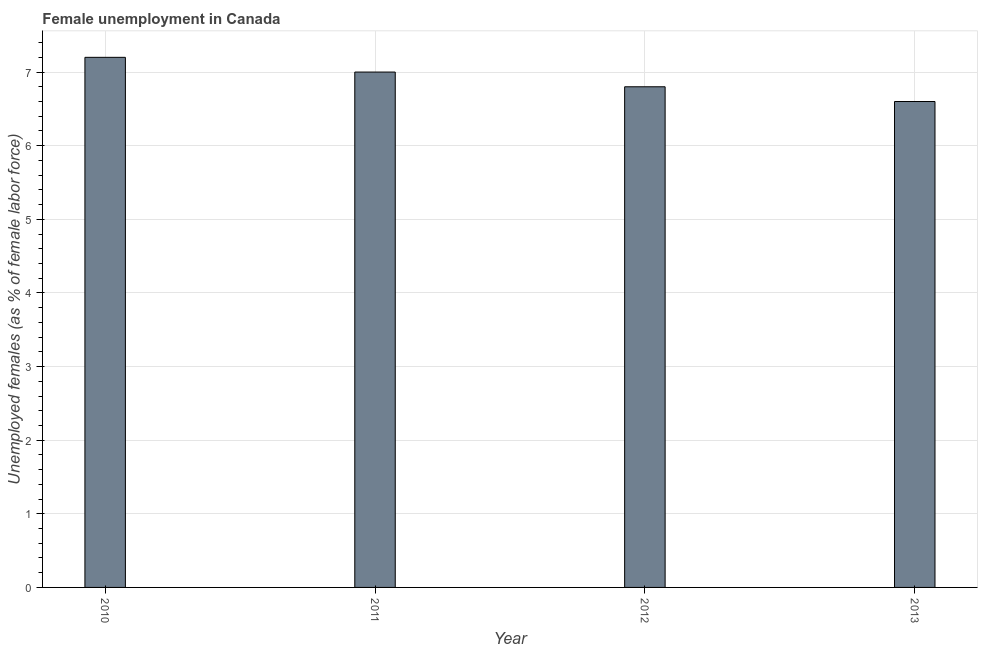What is the title of the graph?
Ensure brevity in your answer.  Female unemployment in Canada. What is the label or title of the Y-axis?
Ensure brevity in your answer.  Unemployed females (as % of female labor force). What is the unemployed females population in 2013?
Keep it short and to the point. 6.6. Across all years, what is the maximum unemployed females population?
Your answer should be compact. 7.2. Across all years, what is the minimum unemployed females population?
Provide a short and direct response. 6.6. In which year was the unemployed females population maximum?
Ensure brevity in your answer.  2010. What is the sum of the unemployed females population?
Offer a very short reply. 27.6. What is the difference between the unemployed females population in 2010 and 2011?
Your answer should be very brief. 0.2. What is the median unemployed females population?
Your response must be concise. 6.9. What is the difference between the highest and the second highest unemployed females population?
Make the answer very short. 0.2. How many bars are there?
Offer a very short reply. 4. Are all the bars in the graph horizontal?
Your answer should be compact. No. Are the values on the major ticks of Y-axis written in scientific E-notation?
Ensure brevity in your answer.  No. What is the Unemployed females (as % of female labor force) in 2010?
Ensure brevity in your answer.  7.2. What is the Unemployed females (as % of female labor force) in 2011?
Provide a short and direct response. 7. What is the Unemployed females (as % of female labor force) in 2012?
Provide a short and direct response. 6.8. What is the Unemployed females (as % of female labor force) in 2013?
Keep it short and to the point. 6.6. What is the difference between the Unemployed females (as % of female labor force) in 2010 and 2013?
Provide a short and direct response. 0.6. What is the difference between the Unemployed females (as % of female labor force) in 2012 and 2013?
Ensure brevity in your answer.  0.2. What is the ratio of the Unemployed females (as % of female labor force) in 2010 to that in 2011?
Your answer should be compact. 1.03. What is the ratio of the Unemployed females (as % of female labor force) in 2010 to that in 2012?
Provide a succinct answer. 1.06. What is the ratio of the Unemployed females (as % of female labor force) in 2010 to that in 2013?
Provide a short and direct response. 1.09. What is the ratio of the Unemployed females (as % of female labor force) in 2011 to that in 2012?
Your answer should be very brief. 1.03. What is the ratio of the Unemployed females (as % of female labor force) in 2011 to that in 2013?
Keep it short and to the point. 1.06. What is the ratio of the Unemployed females (as % of female labor force) in 2012 to that in 2013?
Your answer should be very brief. 1.03. 